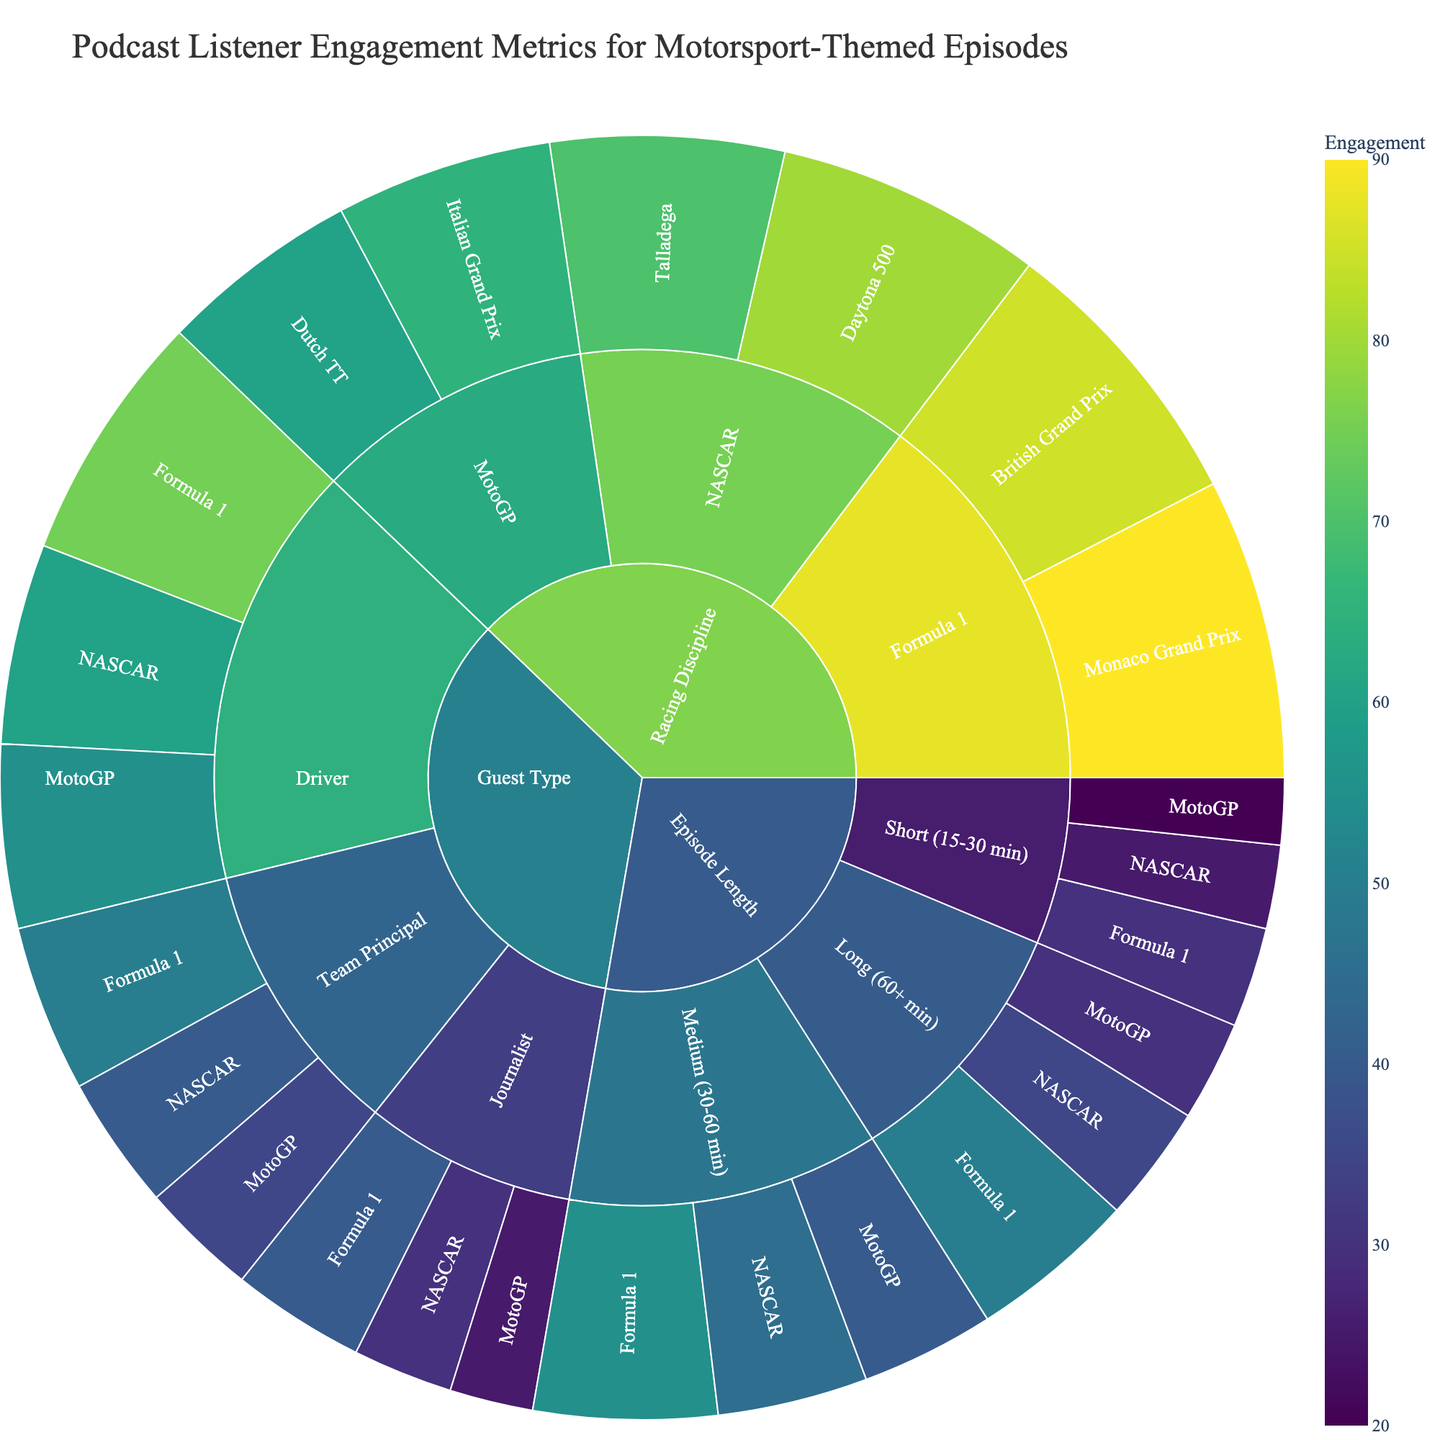What is the title of the Sunburst Plot? The title of the Sunburst Plot is displayed prominently at the top of the figure.
Answer: Podcast Listener Engagement Metrics for Motorsport-Themed Episodes Which guest type has the highest engagement for Formula 1 episodes? In the Sunburst Plot, trace the path from Guest Type to the subcategory labeled ‘Driver’ under Formula 1 to see the engagement value.
Answer: Driver What's the total engagement for episodes discussing the British Grand Prix? Find the engagement value for British Grand Prix under Racing Discipline -> Formula 1.
Answer: 85 Which episode length had the least engagement for NASCAR? Navigate to Episode Length and follow the subcategories to find the smallest value under NASCAR. Compare the values 25 (Short), 45 (Medium), and 35 (Long).
Answer: Short Compare the engagement of episodes featuring journalists across different racing disciplines. Which discipline had the highest engagement? Look under Guest Type -> Journalist for the engagement values across NASCAR (30), Formula 1 (40), and MotoGP (25).
Answer: Formula 1 What’s the average engagement for medium-length episodes across all disciplines? Add the engagement values for medium-length episodes across all disciplines (45 for NASCAR, 55 for Formula 1, 40 for MotoGP), sum them up => 45 + 55 + 40 = 140, then divide by 3.
Answer: 46.67 Within the Racing Discipline category, which specific event had the highest engagement? Compare the engagement values for Daytona 500 (80), Talladega (70), Monaco Grand Prix (90), British Grand Prix (85), Italian Grand Prix (65), and Dutch TT (60).
Answer: Monaco Grand Prix How does the engagement of long episodes discussing Formula 1 compare to short episodes discussing the same discipline? Compare values under Episode Length -> Long -> Formula 1 (50) and Episode Length -> Short -> Formula 1 (30).
Answer: Long episodes have higher engagement What’s the sum of listener engagement for MotoGP episodes with team principals as guests? Find the MotoGP engagement value under Team Principal, labeled 35.
Answer: 35 Which has a higher engagement: short NASCAR episodes or long NASCAR episodes? Compare the values under Episode Length -> Short -> NASCAR (25) and Episode Length -> Long -> NASCAR (35).
Answer: Long NASCAR episodes 